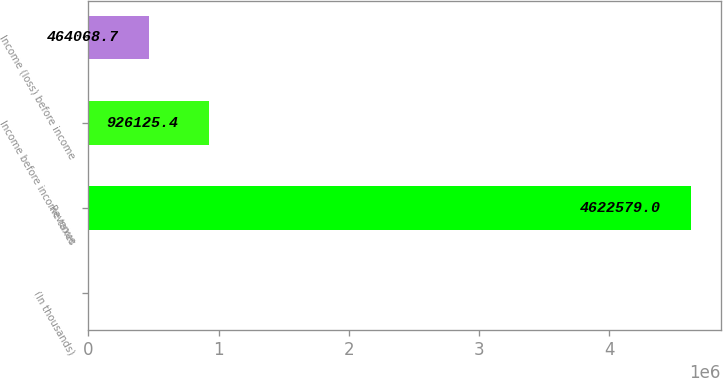Convert chart. <chart><loc_0><loc_0><loc_500><loc_500><bar_chart><fcel>(In thousands)<fcel>Revenue<fcel>Income before income taxes<fcel>Income (loss) before income<nl><fcel>2012<fcel>4.62258e+06<fcel>926125<fcel>464069<nl></chart> 